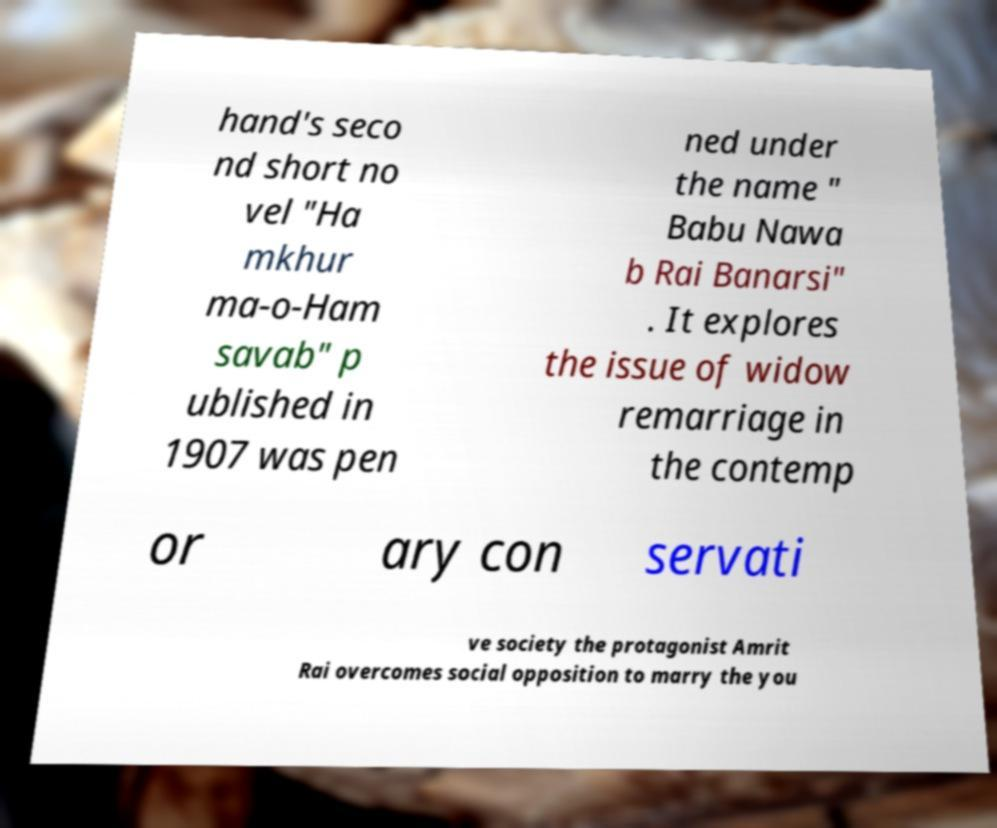I need the written content from this picture converted into text. Can you do that? hand's seco nd short no vel "Ha mkhur ma-o-Ham savab" p ublished in 1907 was pen ned under the name " Babu Nawa b Rai Banarsi" . It explores the issue of widow remarriage in the contemp or ary con servati ve society the protagonist Amrit Rai overcomes social opposition to marry the you 